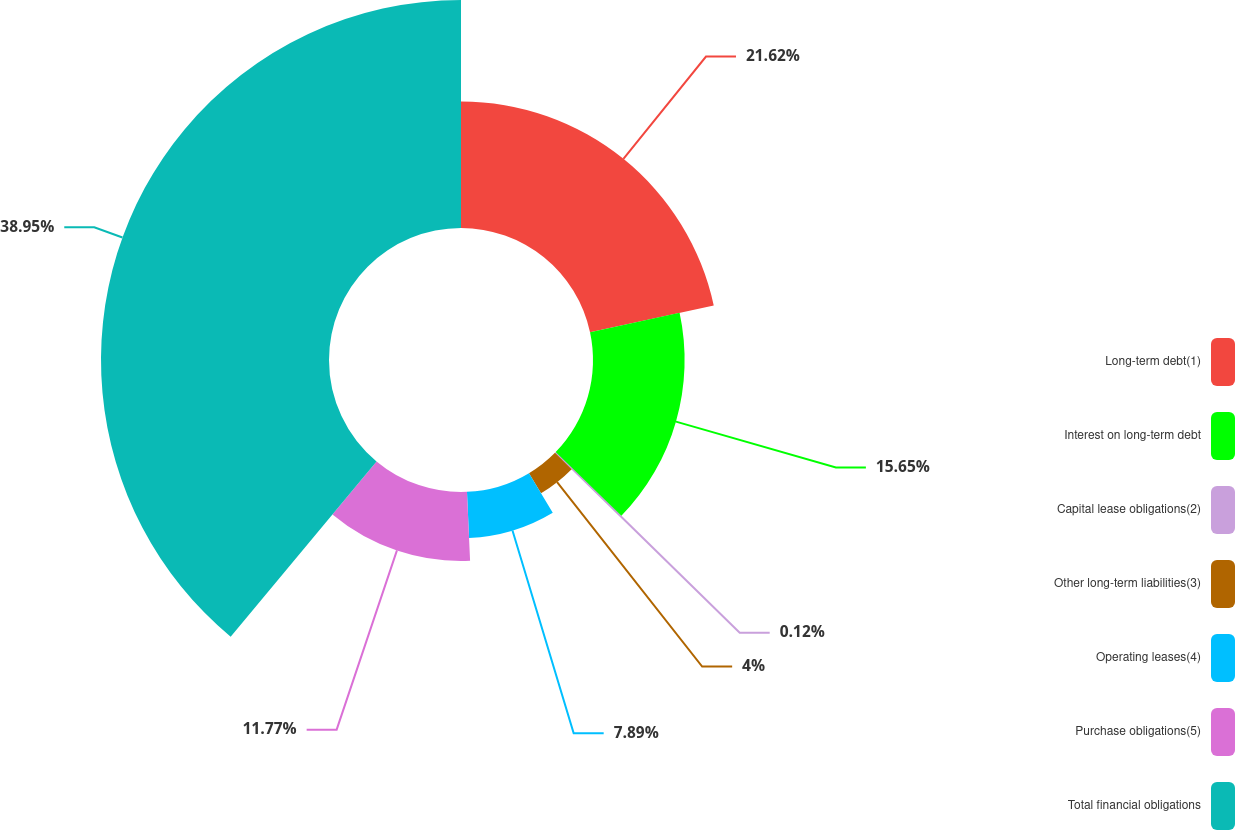<chart> <loc_0><loc_0><loc_500><loc_500><pie_chart><fcel>Long-term debt(1)<fcel>Interest on long-term debt<fcel>Capital lease obligations(2)<fcel>Other long-term liabilities(3)<fcel>Operating leases(4)<fcel>Purchase obligations(5)<fcel>Total financial obligations<nl><fcel>21.62%<fcel>15.65%<fcel>0.12%<fcel>4.0%<fcel>7.89%<fcel>11.77%<fcel>38.95%<nl></chart> 